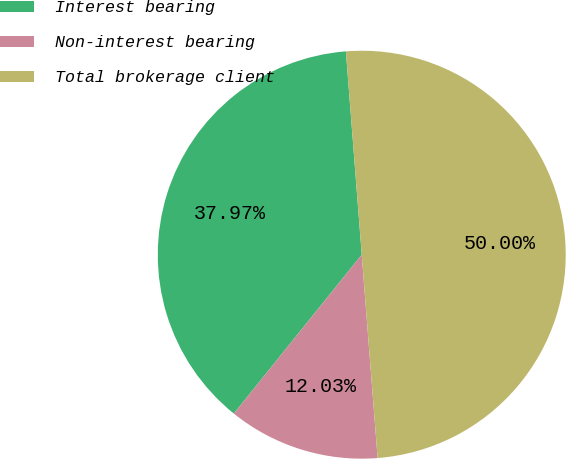Convert chart. <chart><loc_0><loc_0><loc_500><loc_500><pie_chart><fcel>Interest bearing<fcel>Non-interest bearing<fcel>Total brokerage client<nl><fcel>37.97%<fcel>12.03%<fcel>50.0%<nl></chart> 